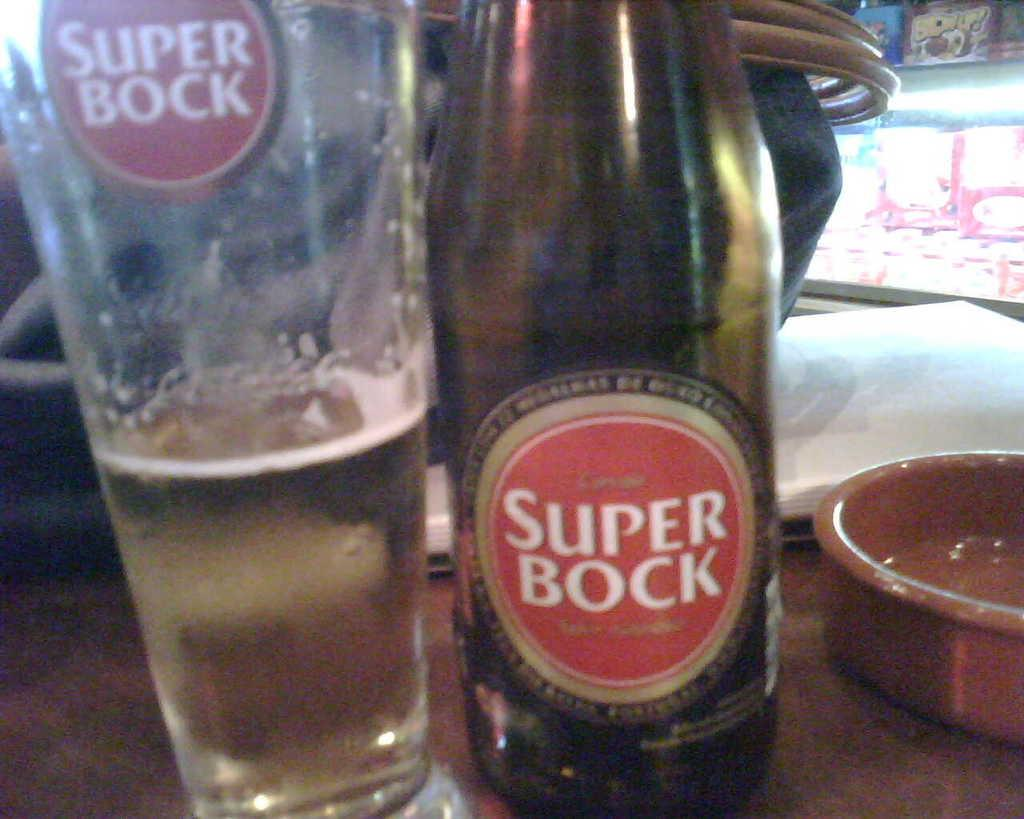<image>
Provide a brief description of the given image. A Half empty class sits next to a bottle of Super Bock. 